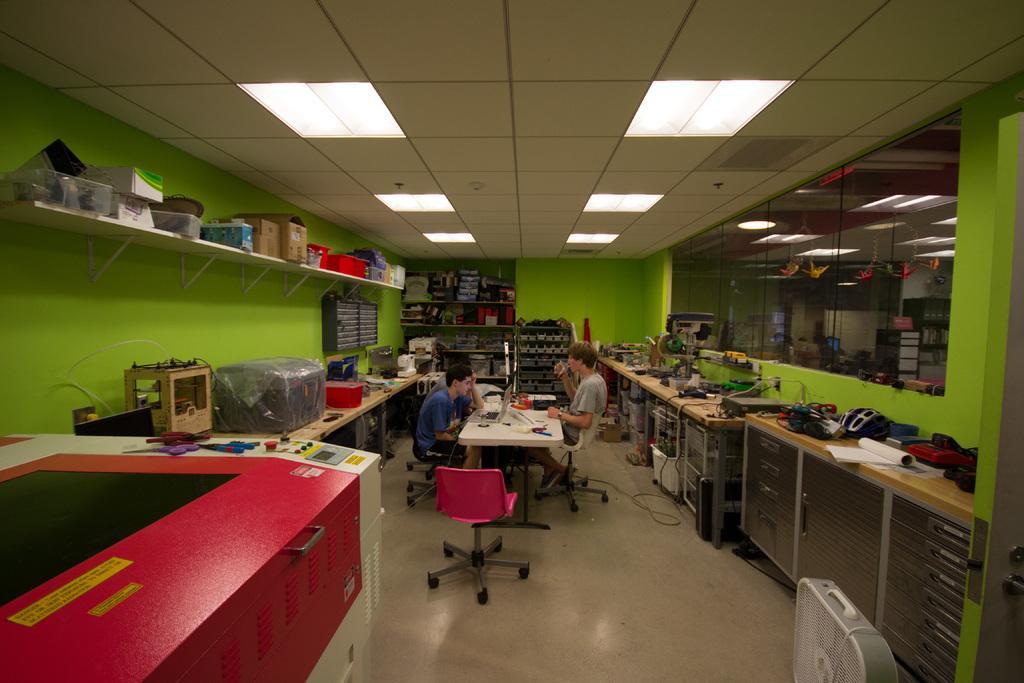Describe this image in one or two sentences. As we can see in the image there is a green color wall, shelves filled with few items, there are boxes over here and on tables there are bags, laptops, suitcase, sewing machine and other few items. There are two people sitting on chairs and there is a table over here. 